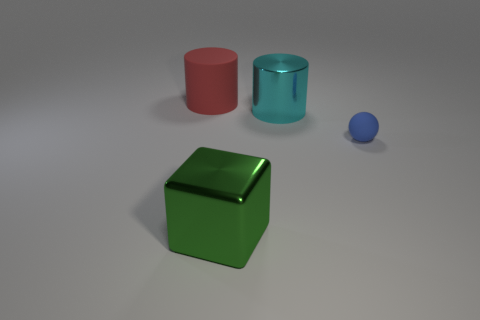Add 1 tiny blue metal cylinders. How many objects exist? 5 Subtract all cubes. How many objects are left? 3 Subtract 1 red cylinders. How many objects are left? 3 Subtract all shiny objects. Subtract all red matte cylinders. How many objects are left? 1 Add 1 small balls. How many small balls are left? 2 Add 2 large red cylinders. How many large red cylinders exist? 3 